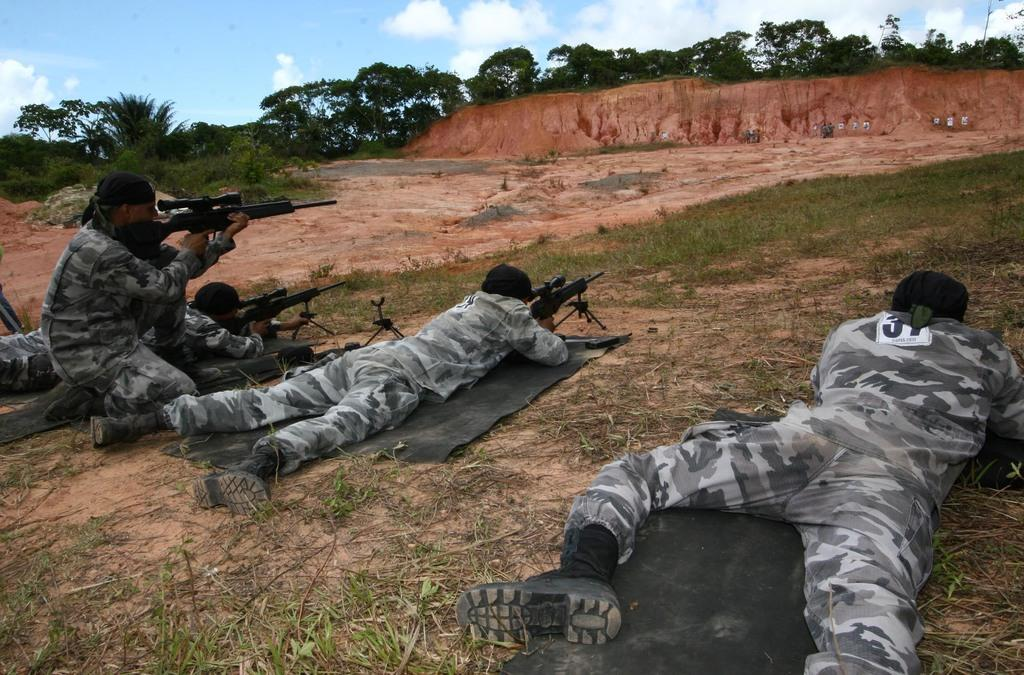What type of personnel can be seen in the image? There are military snipers in the image. What type of terrain is visible in the image? There is grass, trees, hills, and rocks visible in the image. What is visible at the top of the image? The sky is visible at the top of the image. What can be seen in the sky? Clouds are present in the sky. What is the account balance of the military snipers in the image? There is no information about an account balance in the image, as it focuses on the military snipers and their surroundings. Is there a garden visible in the image? No, there is no garden present in the image; it features military snipers in a natural terrain with grass, trees, hills, and rocks. 